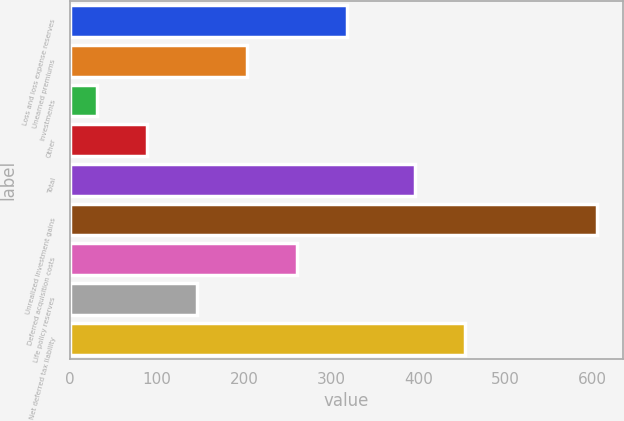Convert chart to OTSL. <chart><loc_0><loc_0><loc_500><loc_500><bar_chart><fcel>Loss and loss expense reserves<fcel>Unearned premiums<fcel>Investments<fcel>Other<fcel>Total<fcel>Unrealized investment gains<fcel>Deferred acquisition costs<fcel>Life policy reserves<fcel>Net deferred tax liability<nl><fcel>318<fcel>203.2<fcel>31<fcel>88.4<fcel>396<fcel>605<fcel>260.6<fcel>145.8<fcel>453.4<nl></chart> 